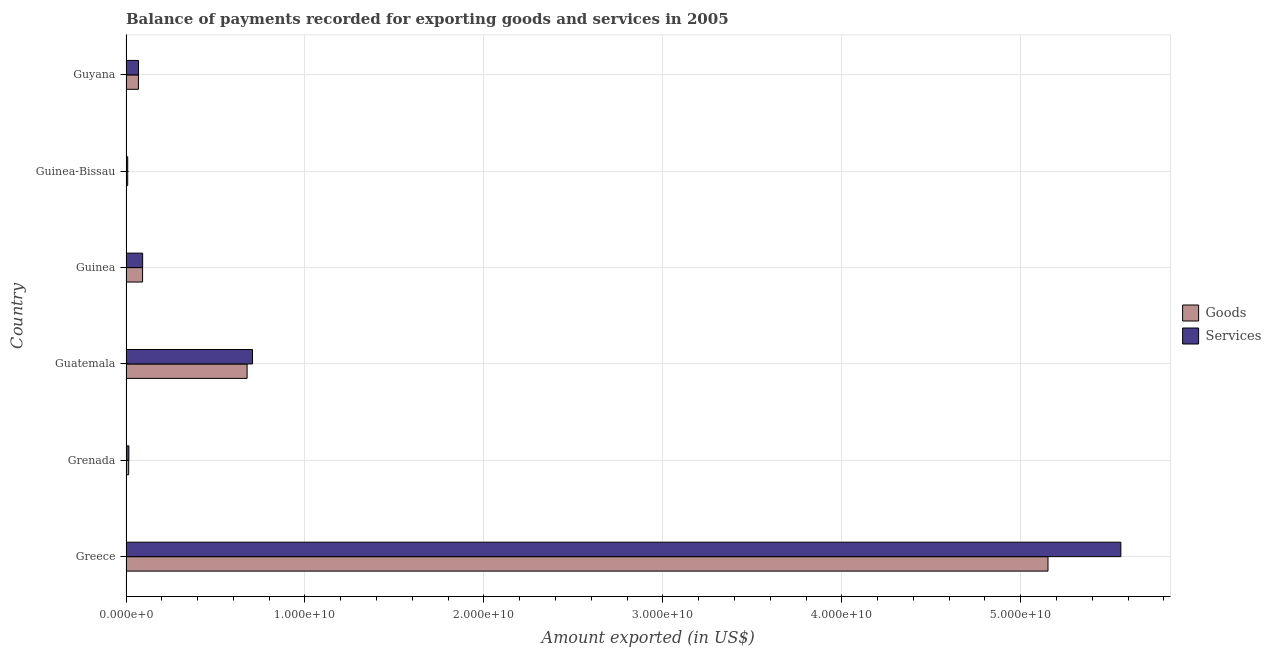What is the label of the 1st group of bars from the top?
Provide a short and direct response. Guyana. What is the amount of services exported in Guyana?
Make the answer very short. 6.97e+08. Across all countries, what is the maximum amount of goods exported?
Keep it short and to the point. 5.15e+1. Across all countries, what is the minimum amount of services exported?
Your answer should be compact. 9.52e+07. In which country was the amount of services exported minimum?
Your answer should be compact. Guinea-Bissau. What is the total amount of services exported in the graph?
Your answer should be compact. 6.45e+1. What is the difference between the amount of goods exported in Guinea and that in Guyana?
Give a very brief answer. 2.32e+08. What is the difference between the amount of goods exported in Grenada and the amount of services exported in Guinea-Bissau?
Your response must be concise. 5.36e+07. What is the average amount of services exported per country?
Offer a terse response. 1.08e+1. What is the difference between the amount of goods exported and amount of services exported in Guatemala?
Keep it short and to the point. -3.02e+08. What is the ratio of the amount of services exported in Guinea-Bissau to that in Guyana?
Your response must be concise. 0.14. Is the amount of goods exported in Greece less than that in Guatemala?
Offer a terse response. No. What is the difference between the highest and the second highest amount of goods exported?
Offer a very short reply. 4.48e+1. What is the difference between the highest and the lowest amount of services exported?
Provide a succinct answer. 5.55e+1. In how many countries, is the amount of goods exported greater than the average amount of goods exported taken over all countries?
Provide a short and direct response. 1. Is the sum of the amount of goods exported in Greece and Guinea-Bissau greater than the maximum amount of services exported across all countries?
Make the answer very short. No. What does the 1st bar from the top in Grenada represents?
Give a very brief answer. Services. What does the 1st bar from the bottom in Guyana represents?
Provide a succinct answer. Goods. How many bars are there?
Offer a very short reply. 12. Are all the bars in the graph horizontal?
Provide a short and direct response. Yes. What is the difference between two consecutive major ticks on the X-axis?
Provide a succinct answer. 1.00e+1. Does the graph contain any zero values?
Offer a terse response. No. Does the graph contain grids?
Ensure brevity in your answer.  Yes. Where does the legend appear in the graph?
Offer a terse response. Center right. How many legend labels are there?
Your answer should be compact. 2. How are the legend labels stacked?
Offer a very short reply. Vertical. What is the title of the graph?
Provide a succinct answer. Balance of payments recorded for exporting goods and services in 2005. Does "Current US$" appear as one of the legend labels in the graph?
Keep it short and to the point. No. What is the label or title of the X-axis?
Offer a very short reply. Amount exported (in US$). What is the label or title of the Y-axis?
Keep it short and to the point. Country. What is the Amount exported (in US$) in Goods in Greece?
Keep it short and to the point. 5.15e+1. What is the Amount exported (in US$) of Services in Greece?
Ensure brevity in your answer.  5.56e+1. What is the Amount exported (in US$) in Goods in Grenada?
Offer a terse response. 1.49e+08. What is the Amount exported (in US$) in Services in Grenada?
Give a very brief answer. 1.60e+08. What is the Amount exported (in US$) of Goods in Guatemala?
Ensure brevity in your answer.  6.77e+09. What is the Amount exported (in US$) of Services in Guatemala?
Your answer should be compact. 7.07e+09. What is the Amount exported (in US$) of Goods in Guinea?
Offer a terse response. 9.26e+08. What is the Amount exported (in US$) in Services in Guinea?
Give a very brief answer. 9.29e+08. What is the Amount exported (in US$) of Goods in Guinea-Bissau?
Your answer should be compact. 9.48e+07. What is the Amount exported (in US$) in Services in Guinea-Bissau?
Offer a very short reply. 9.52e+07. What is the Amount exported (in US$) of Goods in Guyana?
Offer a terse response. 6.93e+08. What is the Amount exported (in US$) of Services in Guyana?
Your answer should be compact. 6.97e+08. Across all countries, what is the maximum Amount exported (in US$) in Goods?
Offer a terse response. 5.15e+1. Across all countries, what is the maximum Amount exported (in US$) in Services?
Your answer should be compact. 5.56e+1. Across all countries, what is the minimum Amount exported (in US$) in Goods?
Your answer should be very brief. 9.48e+07. Across all countries, what is the minimum Amount exported (in US$) in Services?
Provide a short and direct response. 9.52e+07. What is the total Amount exported (in US$) of Goods in the graph?
Offer a terse response. 6.02e+1. What is the total Amount exported (in US$) in Services in the graph?
Provide a short and direct response. 6.45e+1. What is the difference between the Amount exported (in US$) of Goods in Greece and that in Grenada?
Provide a short and direct response. 5.14e+1. What is the difference between the Amount exported (in US$) in Services in Greece and that in Grenada?
Your answer should be very brief. 5.54e+1. What is the difference between the Amount exported (in US$) of Goods in Greece and that in Guatemala?
Provide a succinct answer. 4.48e+1. What is the difference between the Amount exported (in US$) of Services in Greece and that in Guatemala?
Your response must be concise. 4.85e+1. What is the difference between the Amount exported (in US$) of Goods in Greece and that in Guinea?
Make the answer very short. 5.06e+1. What is the difference between the Amount exported (in US$) of Services in Greece and that in Guinea?
Your response must be concise. 5.47e+1. What is the difference between the Amount exported (in US$) in Goods in Greece and that in Guinea-Bissau?
Ensure brevity in your answer.  5.14e+1. What is the difference between the Amount exported (in US$) in Services in Greece and that in Guinea-Bissau?
Give a very brief answer. 5.55e+1. What is the difference between the Amount exported (in US$) in Goods in Greece and that in Guyana?
Offer a very short reply. 5.08e+1. What is the difference between the Amount exported (in US$) of Services in Greece and that in Guyana?
Offer a very short reply. 5.49e+1. What is the difference between the Amount exported (in US$) of Goods in Grenada and that in Guatemala?
Offer a terse response. -6.62e+09. What is the difference between the Amount exported (in US$) in Services in Grenada and that in Guatemala?
Offer a terse response. -6.91e+09. What is the difference between the Amount exported (in US$) of Goods in Grenada and that in Guinea?
Provide a succinct answer. -7.77e+08. What is the difference between the Amount exported (in US$) of Services in Grenada and that in Guinea?
Your answer should be very brief. -7.69e+08. What is the difference between the Amount exported (in US$) of Goods in Grenada and that in Guinea-Bissau?
Your answer should be compact. 5.41e+07. What is the difference between the Amount exported (in US$) in Services in Grenada and that in Guinea-Bissau?
Give a very brief answer. 6.51e+07. What is the difference between the Amount exported (in US$) of Goods in Grenada and that in Guyana?
Provide a succinct answer. -5.45e+08. What is the difference between the Amount exported (in US$) in Services in Grenada and that in Guyana?
Your answer should be compact. -5.36e+08. What is the difference between the Amount exported (in US$) of Goods in Guatemala and that in Guinea?
Your answer should be compact. 5.84e+09. What is the difference between the Amount exported (in US$) in Services in Guatemala and that in Guinea?
Make the answer very short. 6.14e+09. What is the difference between the Amount exported (in US$) of Goods in Guatemala and that in Guinea-Bissau?
Keep it short and to the point. 6.67e+09. What is the difference between the Amount exported (in US$) in Services in Guatemala and that in Guinea-Bissau?
Offer a very short reply. 6.97e+09. What is the difference between the Amount exported (in US$) of Goods in Guatemala and that in Guyana?
Give a very brief answer. 6.07e+09. What is the difference between the Amount exported (in US$) in Services in Guatemala and that in Guyana?
Ensure brevity in your answer.  6.37e+09. What is the difference between the Amount exported (in US$) in Goods in Guinea and that in Guinea-Bissau?
Keep it short and to the point. 8.31e+08. What is the difference between the Amount exported (in US$) of Services in Guinea and that in Guinea-Bissau?
Provide a short and direct response. 8.34e+08. What is the difference between the Amount exported (in US$) in Goods in Guinea and that in Guyana?
Keep it short and to the point. 2.32e+08. What is the difference between the Amount exported (in US$) of Services in Guinea and that in Guyana?
Your answer should be compact. 2.32e+08. What is the difference between the Amount exported (in US$) in Goods in Guinea-Bissau and that in Guyana?
Your answer should be very brief. -5.99e+08. What is the difference between the Amount exported (in US$) in Services in Guinea-Bissau and that in Guyana?
Give a very brief answer. -6.02e+08. What is the difference between the Amount exported (in US$) of Goods in Greece and the Amount exported (in US$) of Services in Grenada?
Make the answer very short. 5.14e+1. What is the difference between the Amount exported (in US$) of Goods in Greece and the Amount exported (in US$) of Services in Guatemala?
Offer a very short reply. 4.45e+1. What is the difference between the Amount exported (in US$) of Goods in Greece and the Amount exported (in US$) of Services in Guinea?
Give a very brief answer. 5.06e+1. What is the difference between the Amount exported (in US$) of Goods in Greece and the Amount exported (in US$) of Services in Guinea-Bissau?
Ensure brevity in your answer.  5.14e+1. What is the difference between the Amount exported (in US$) in Goods in Greece and the Amount exported (in US$) in Services in Guyana?
Give a very brief answer. 5.08e+1. What is the difference between the Amount exported (in US$) in Goods in Grenada and the Amount exported (in US$) in Services in Guatemala?
Provide a short and direct response. -6.92e+09. What is the difference between the Amount exported (in US$) in Goods in Grenada and the Amount exported (in US$) in Services in Guinea?
Provide a succinct answer. -7.80e+08. What is the difference between the Amount exported (in US$) in Goods in Grenada and the Amount exported (in US$) in Services in Guinea-Bissau?
Provide a short and direct response. 5.36e+07. What is the difference between the Amount exported (in US$) of Goods in Grenada and the Amount exported (in US$) of Services in Guyana?
Give a very brief answer. -5.48e+08. What is the difference between the Amount exported (in US$) of Goods in Guatemala and the Amount exported (in US$) of Services in Guinea?
Provide a succinct answer. 5.84e+09. What is the difference between the Amount exported (in US$) of Goods in Guatemala and the Amount exported (in US$) of Services in Guinea-Bissau?
Offer a very short reply. 6.67e+09. What is the difference between the Amount exported (in US$) in Goods in Guatemala and the Amount exported (in US$) in Services in Guyana?
Your response must be concise. 6.07e+09. What is the difference between the Amount exported (in US$) in Goods in Guinea and the Amount exported (in US$) in Services in Guinea-Bissau?
Keep it short and to the point. 8.30e+08. What is the difference between the Amount exported (in US$) in Goods in Guinea and the Amount exported (in US$) in Services in Guyana?
Your response must be concise. 2.29e+08. What is the difference between the Amount exported (in US$) in Goods in Guinea-Bissau and the Amount exported (in US$) in Services in Guyana?
Your response must be concise. -6.02e+08. What is the average Amount exported (in US$) of Goods per country?
Keep it short and to the point. 1.00e+1. What is the average Amount exported (in US$) of Services per country?
Your answer should be very brief. 1.08e+1. What is the difference between the Amount exported (in US$) of Goods and Amount exported (in US$) of Services in Greece?
Make the answer very short. -4.07e+09. What is the difference between the Amount exported (in US$) of Goods and Amount exported (in US$) of Services in Grenada?
Your answer should be compact. -1.14e+07. What is the difference between the Amount exported (in US$) in Goods and Amount exported (in US$) in Services in Guatemala?
Ensure brevity in your answer.  -3.02e+08. What is the difference between the Amount exported (in US$) of Goods and Amount exported (in US$) of Services in Guinea?
Your answer should be very brief. -3.20e+06. What is the difference between the Amount exported (in US$) in Goods and Amount exported (in US$) in Services in Guinea-Bissau?
Offer a terse response. -4.42e+05. What is the difference between the Amount exported (in US$) of Goods and Amount exported (in US$) of Services in Guyana?
Offer a very short reply. -3.26e+06. What is the ratio of the Amount exported (in US$) of Goods in Greece to that in Grenada?
Provide a short and direct response. 346.08. What is the ratio of the Amount exported (in US$) of Services in Greece to that in Grenada?
Provide a short and direct response. 346.8. What is the ratio of the Amount exported (in US$) in Goods in Greece to that in Guatemala?
Keep it short and to the point. 7.61. What is the ratio of the Amount exported (in US$) in Services in Greece to that in Guatemala?
Your answer should be very brief. 7.86. What is the ratio of the Amount exported (in US$) of Goods in Greece to that in Guinea?
Offer a very short reply. 55.66. What is the ratio of the Amount exported (in US$) in Services in Greece to that in Guinea?
Offer a terse response. 59.85. What is the ratio of the Amount exported (in US$) in Goods in Greece to that in Guinea-Bissau?
Your answer should be compact. 543.55. What is the ratio of the Amount exported (in US$) of Services in Greece to that in Guinea-Bissau?
Provide a succinct answer. 583.79. What is the ratio of the Amount exported (in US$) of Goods in Greece to that in Guyana?
Offer a terse response. 74.29. What is the ratio of the Amount exported (in US$) in Services in Greece to that in Guyana?
Your response must be concise. 79.79. What is the ratio of the Amount exported (in US$) in Goods in Grenada to that in Guatemala?
Offer a very short reply. 0.02. What is the ratio of the Amount exported (in US$) of Services in Grenada to that in Guatemala?
Your answer should be very brief. 0.02. What is the ratio of the Amount exported (in US$) of Goods in Grenada to that in Guinea?
Keep it short and to the point. 0.16. What is the ratio of the Amount exported (in US$) in Services in Grenada to that in Guinea?
Provide a short and direct response. 0.17. What is the ratio of the Amount exported (in US$) of Goods in Grenada to that in Guinea-Bissau?
Make the answer very short. 1.57. What is the ratio of the Amount exported (in US$) in Services in Grenada to that in Guinea-Bissau?
Your response must be concise. 1.68. What is the ratio of the Amount exported (in US$) in Goods in Grenada to that in Guyana?
Keep it short and to the point. 0.21. What is the ratio of the Amount exported (in US$) of Services in Grenada to that in Guyana?
Make the answer very short. 0.23. What is the ratio of the Amount exported (in US$) in Goods in Guatemala to that in Guinea?
Make the answer very short. 7.31. What is the ratio of the Amount exported (in US$) in Services in Guatemala to that in Guinea?
Your answer should be very brief. 7.61. What is the ratio of the Amount exported (in US$) in Goods in Guatemala to that in Guinea-Bissau?
Your answer should be very brief. 71.39. What is the ratio of the Amount exported (in US$) of Services in Guatemala to that in Guinea-Bissau?
Your answer should be compact. 74.23. What is the ratio of the Amount exported (in US$) in Goods in Guatemala to that in Guyana?
Keep it short and to the point. 9.76. What is the ratio of the Amount exported (in US$) of Services in Guatemala to that in Guyana?
Make the answer very short. 10.15. What is the ratio of the Amount exported (in US$) of Goods in Guinea to that in Guinea-Bissau?
Keep it short and to the point. 9.77. What is the ratio of the Amount exported (in US$) in Services in Guinea to that in Guinea-Bissau?
Offer a terse response. 9.75. What is the ratio of the Amount exported (in US$) of Goods in Guinea to that in Guyana?
Your response must be concise. 1.33. What is the ratio of the Amount exported (in US$) of Services in Guinea to that in Guyana?
Give a very brief answer. 1.33. What is the ratio of the Amount exported (in US$) of Goods in Guinea-Bissau to that in Guyana?
Offer a terse response. 0.14. What is the ratio of the Amount exported (in US$) in Services in Guinea-Bissau to that in Guyana?
Offer a very short reply. 0.14. What is the difference between the highest and the second highest Amount exported (in US$) of Goods?
Ensure brevity in your answer.  4.48e+1. What is the difference between the highest and the second highest Amount exported (in US$) in Services?
Provide a short and direct response. 4.85e+1. What is the difference between the highest and the lowest Amount exported (in US$) of Goods?
Your answer should be very brief. 5.14e+1. What is the difference between the highest and the lowest Amount exported (in US$) in Services?
Offer a terse response. 5.55e+1. 